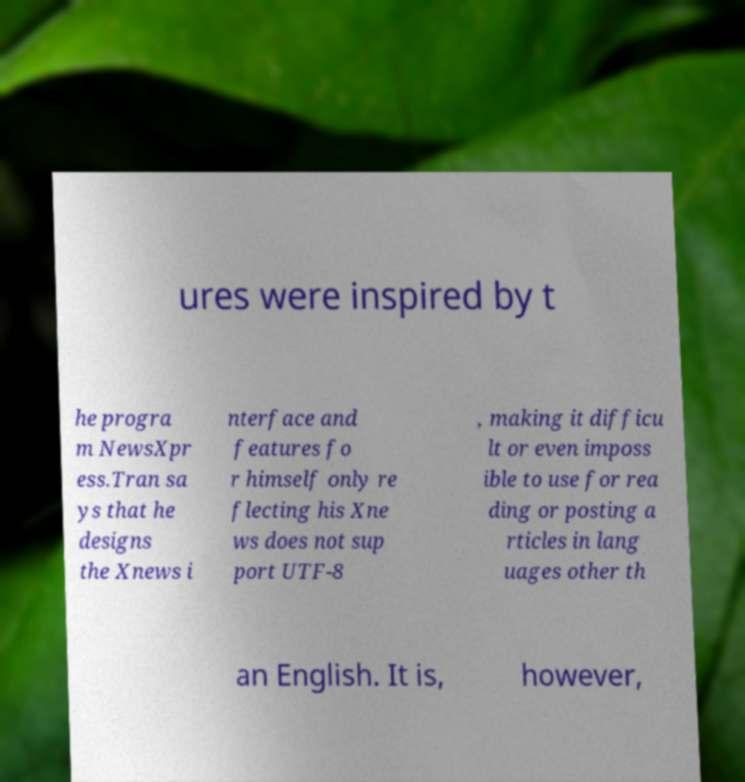There's text embedded in this image that I need extracted. Can you transcribe it verbatim? ures were inspired by t he progra m NewsXpr ess.Tran sa ys that he designs the Xnews i nterface and features fo r himself only re flecting his Xne ws does not sup port UTF-8 , making it difficu lt or even imposs ible to use for rea ding or posting a rticles in lang uages other th an English. It is, however, 